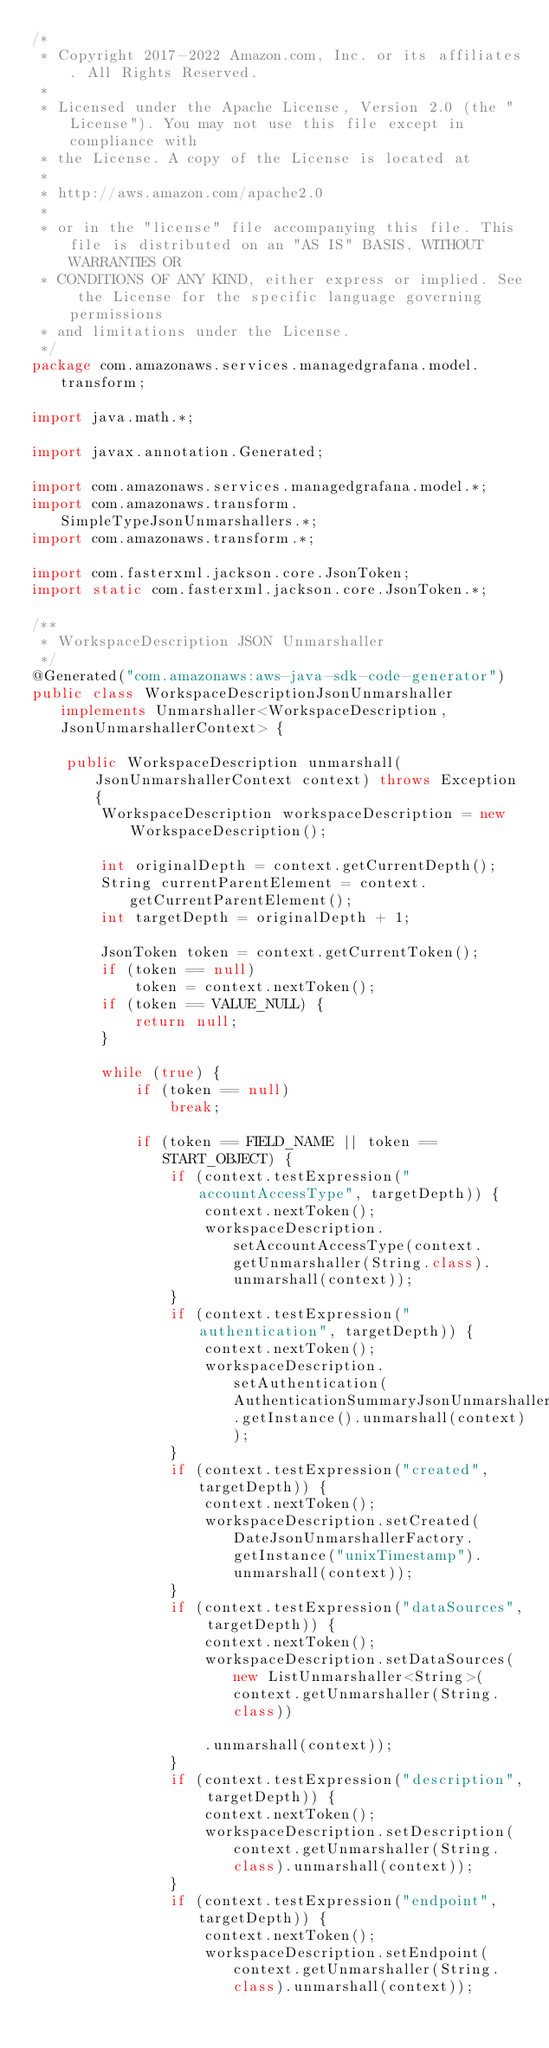Convert code to text. <code><loc_0><loc_0><loc_500><loc_500><_Java_>/*
 * Copyright 2017-2022 Amazon.com, Inc. or its affiliates. All Rights Reserved.
 * 
 * Licensed under the Apache License, Version 2.0 (the "License"). You may not use this file except in compliance with
 * the License. A copy of the License is located at
 * 
 * http://aws.amazon.com/apache2.0
 * 
 * or in the "license" file accompanying this file. This file is distributed on an "AS IS" BASIS, WITHOUT WARRANTIES OR
 * CONDITIONS OF ANY KIND, either express or implied. See the License for the specific language governing permissions
 * and limitations under the License.
 */
package com.amazonaws.services.managedgrafana.model.transform;

import java.math.*;

import javax.annotation.Generated;

import com.amazonaws.services.managedgrafana.model.*;
import com.amazonaws.transform.SimpleTypeJsonUnmarshallers.*;
import com.amazonaws.transform.*;

import com.fasterxml.jackson.core.JsonToken;
import static com.fasterxml.jackson.core.JsonToken.*;

/**
 * WorkspaceDescription JSON Unmarshaller
 */
@Generated("com.amazonaws:aws-java-sdk-code-generator")
public class WorkspaceDescriptionJsonUnmarshaller implements Unmarshaller<WorkspaceDescription, JsonUnmarshallerContext> {

    public WorkspaceDescription unmarshall(JsonUnmarshallerContext context) throws Exception {
        WorkspaceDescription workspaceDescription = new WorkspaceDescription();

        int originalDepth = context.getCurrentDepth();
        String currentParentElement = context.getCurrentParentElement();
        int targetDepth = originalDepth + 1;

        JsonToken token = context.getCurrentToken();
        if (token == null)
            token = context.nextToken();
        if (token == VALUE_NULL) {
            return null;
        }

        while (true) {
            if (token == null)
                break;

            if (token == FIELD_NAME || token == START_OBJECT) {
                if (context.testExpression("accountAccessType", targetDepth)) {
                    context.nextToken();
                    workspaceDescription.setAccountAccessType(context.getUnmarshaller(String.class).unmarshall(context));
                }
                if (context.testExpression("authentication", targetDepth)) {
                    context.nextToken();
                    workspaceDescription.setAuthentication(AuthenticationSummaryJsonUnmarshaller.getInstance().unmarshall(context));
                }
                if (context.testExpression("created", targetDepth)) {
                    context.nextToken();
                    workspaceDescription.setCreated(DateJsonUnmarshallerFactory.getInstance("unixTimestamp").unmarshall(context));
                }
                if (context.testExpression("dataSources", targetDepth)) {
                    context.nextToken();
                    workspaceDescription.setDataSources(new ListUnmarshaller<String>(context.getUnmarshaller(String.class))

                    .unmarshall(context));
                }
                if (context.testExpression("description", targetDepth)) {
                    context.nextToken();
                    workspaceDescription.setDescription(context.getUnmarshaller(String.class).unmarshall(context));
                }
                if (context.testExpression("endpoint", targetDepth)) {
                    context.nextToken();
                    workspaceDescription.setEndpoint(context.getUnmarshaller(String.class).unmarshall(context));</code> 